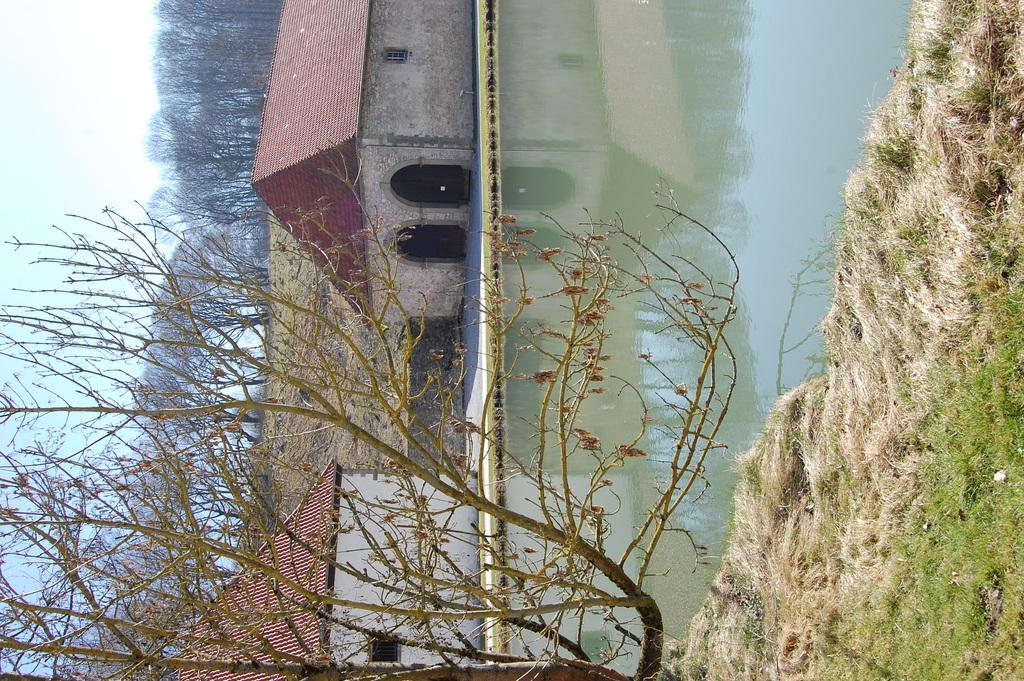What type of vegetation can be seen in the image? There is grass in the image. What else can be seen besides grass? There is water, houses, trees, and the sky visible in the image. Can you describe the houses in the image? The houses are part of the landscape in the image. What is visible in the background of the image? The sky is visible in the background of the image. How many sheep are blowing their sweaters in the image? There are no sheep or sweaters present in the image. What type of sweater is being blown by the wind in the image? There is no sweater being blown by the wind in the image. 